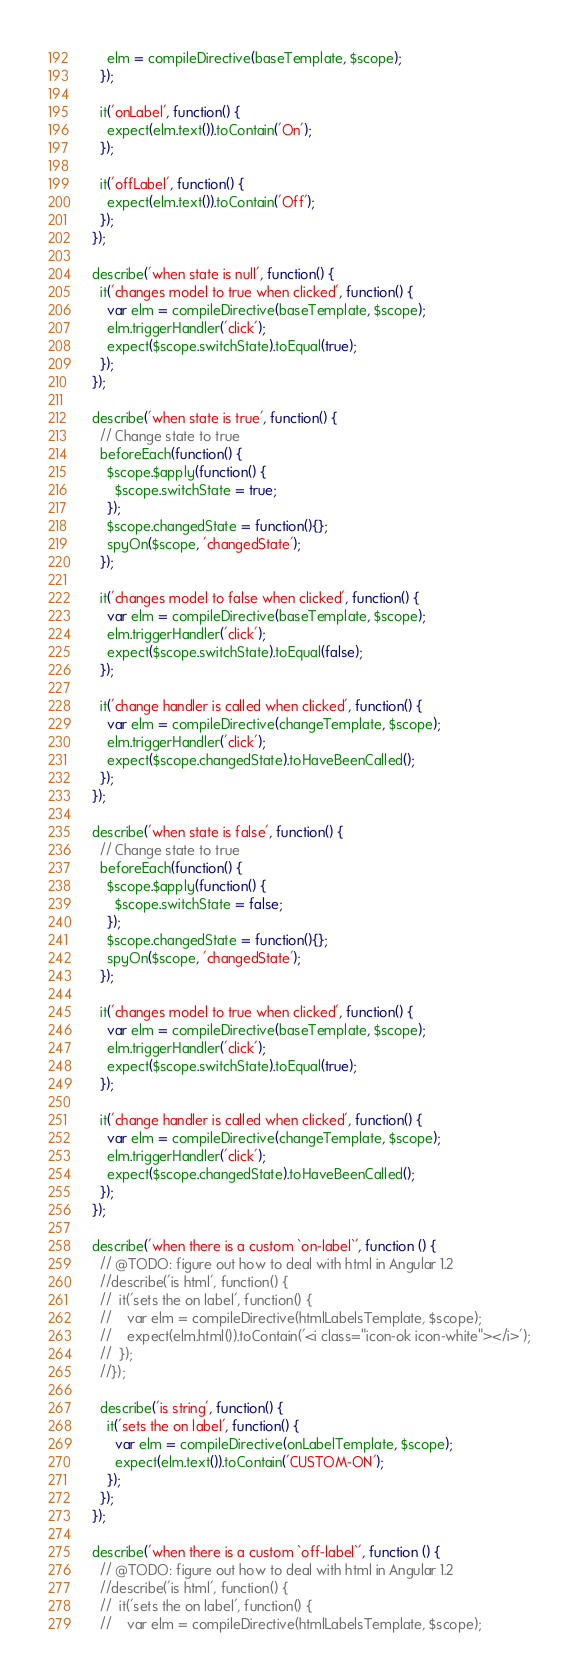<code> <loc_0><loc_0><loc_500><loc_500><_JavaScript_>      elm = compileDirective(baseTemplate, $scope);
    });

    it('onLabel', function() {
      expect(elm.text()).toContain('On');
    });

    it('offLabel', function() {
      expect(elm.text()).toContain('Off');
    });
  });

  describe('when state is null', function() {
    it('changes model to true when clicked', function() {
      var elm = compileDirective(baseTemplate, $scope);
      elm.triggerHandler('click');
      expect($scope.switchState).toEqual(true);
    });
  });

  describe('when state is true', function() {
    // Change state to true
    beforeEach(function() {
      $scope.$apply(function() {
        $scope.switchState = true;
      });
      $scope.changedState = function(){};
      spyOn($scope, 'changedState');
    });

    it('changes model to false when clicked', function() {
      var elm = compileDirective(baseTemplate, $scope);
      elm.triggerHandler('click');
      expect($scope.switchState).toEqual(false);
    });

    it('change handler is called when clicked', function() {
      var elm = compileDirective(changeTemplate, $scope);
      elm.triggerHandler('click');
      expect($scope.changedState).toHaveBeenCalled();
    });
  });

  describe('when state is false', function() {
    // Change state to true
    beforeEach(function() {
      $scope.$apply(function() {
        $scope.switchState = false;
      });
      $scope.changedState = function(){};
      spyOn($scope, 'changedState');
    });

    it('changes model to true when clicked', function() {
      var elm = compileDirective(baseTemplate, $scope);
      elm.triggerHandler('click');
      expect($scope.switchState).toEqual(true);
    });

    it('change handler is called when clicked', function() {
      var elm = compileDirective(changeTemplate, $scope);
      elm.triggerHandler('click');
      expect($scope.changedState).toHaveBeenCalled();
    });
  });

  describe('when there is a custom `on-label`', function () {
    // @TODO: figure out how to deal with html in Angular 1.2
    //describe('is html', function() {
    //  it('sets the on label', function() {
    //    var elm = compileDirective(htmlLabelsTemplate, $scope);
    //    expect(elm.html()).toContain('<i class="icon-ok icon-white"></i>');
    //  });
    //});

    describe('is string', function() {
      it('sets the on label', function() {
        var elm = compileDirective(onLabelTemplate, $scope);
        expect(elm.text()).toContain('CUSTOM-ON');
      });
    });
  });

  describe('when there is a custom `off-label`', function () {
    // @TODO: figure out how to deal with html in Angular 1.2
    //describe('is html', function() {
    //  it('sets the on label', function() {
    //    var elm = compileDirective(htmlLabelsTemplate, $scope);</code> 